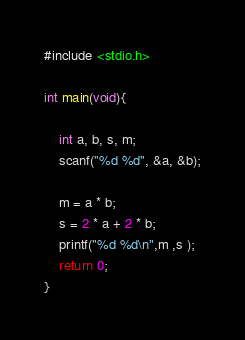<code> <loc_0><loc_0><loc_500><loc_500><_C_>#include <stdio.h>

int main(void){
	
	int a, b, s, m;
	scanf("%d %d", &a, &b);
	
	m = a * b;
	s = 2 * a + 2 * b;
	printf("%d %d\n",m ,s );
	return 0;
}</code> 